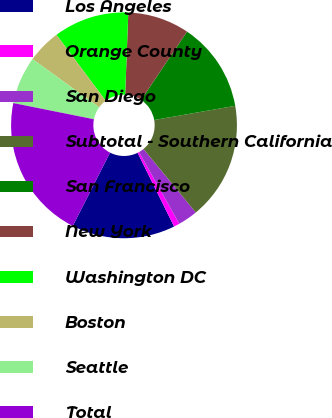<chart> <loc_0><loc_0><loc_500><loc_500><pie_chart><fcel>Los Angeles<fcel>Orange County<fcel>San Diego<fcel>Subtotal - Southern California<fcel>San Francisco<fcel>New York<fcel>Washington DC<fcel>Boston<fcel>Seattle<fcel>Total<nl><fcel>14.81%<fcel>0.83%<fcel>2.82%<fcel>16.8%<fcel>12.81%<fcel>8.82%<fcel>10.81%<fcel>4.82%<fcel>6.82%<fcel>20.66%<nl></chart> 